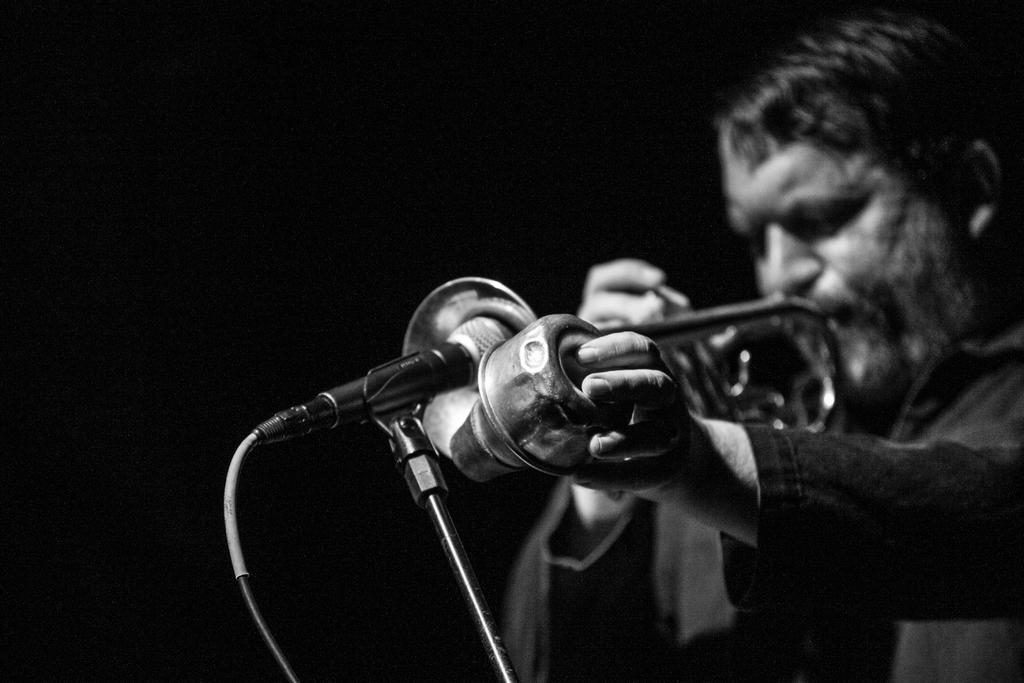What is the man in the image doing? The man is playing a trumpet in the image. What object is present in the image that might be used for amplifying sound? There is a microphone in the image. How many trees are visible in the image? There are no trees visible in the image; it only features a man playing a trumpet and a microphone. 